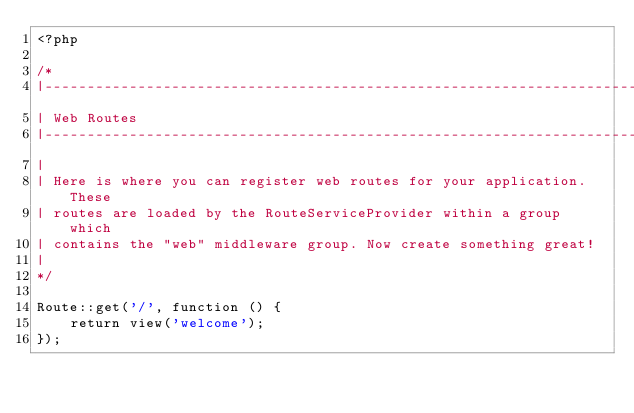Convert code to text. <code><loc_0><loc_0><loc_500><loc_500><_PHP_><?php

/*
|--------------------------------------------------------------------------
| Web Routes
|--------------------------------------------------------------------------
|
| Here is where you can register web routes for your application. These
| routes are loaded by the RouteServiceProvider within a group which
| contains the "web" middleware group. Now create something great!
|
*/

Route::get('/', function () {
    return view('welcome');
});



</code> 